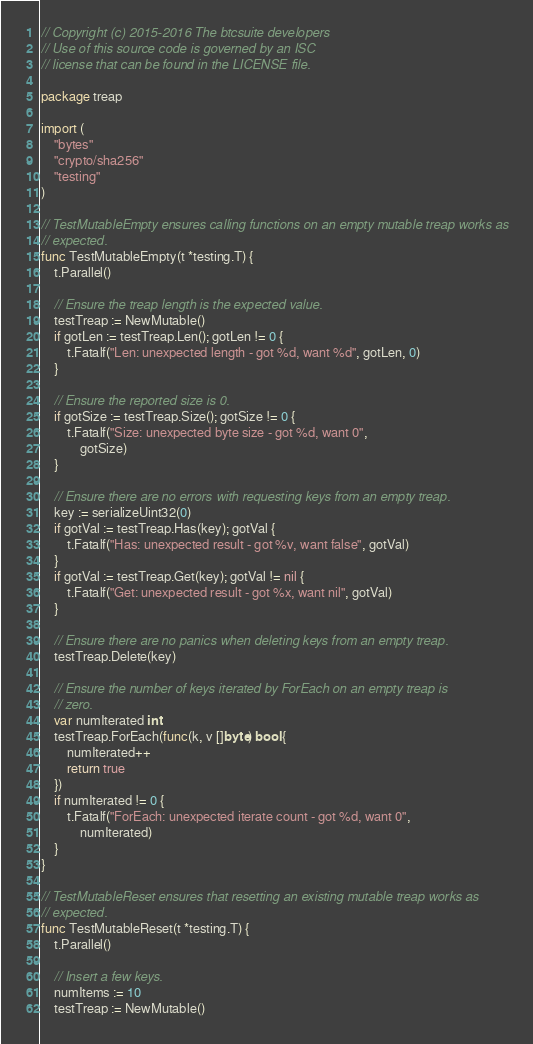Convert code to text. <code><loc_0><loc_0><loc_500><loc_500><_Go_>// Copyright (c) 2015-2016 The btcsuite developers
// Use of this source code is governed by an ISC
// license that can be found in the LICENSE file.

package treap

import (
	"bytes"
	"crypto/sha256"
	"testing"
)

// TestMutableEmpty ensures calling functions on an empty mutable treap works as
// expected.
func TestMutableEmpty(t *testing.T) {
	t.Parallel()

	// Ensure the treap length is the expected value.
	testTreap := NewMutable()
	if gotLen := testTreap.Len(); gotLen != 0 {
		t.Fatalf("Len: unexpected length - got %d, want %d", gotLen, 0)
	}

	// Ensure the reported size is 0.
	if gotSize := testTreap.Size(); gotSize != 0 {
		t.Fatalf("Size: unexpected byte size - got %d, want 0",
			gotSize)
	}

	// Ensure there are no errors with requesting keys from an empty treap.
	key := serializeUint32(0)
	if gotVal := testTreap.Has(key); gotVal {
		t.Fatalf("Has: unexpected result - got %v, want false", gotVal)
	}
	if gotVal := testTreap.Get(key); gotVal != nil {
		t.Fatalf("Get: unexpected result - got %x, want nil", gotVal)
	}

	// Ensure there are no panics when deleting keys from an empty treap.
	testTreap.Delete(key)

	// Ensure the number of keys iterated by ForEach on an empty treap is
	// zero.
	var numIterated int
	testTreap.ForEach(func(k, v []byte) bool {
		numIterated++
		return true
	})
	if numIterated != 0 {
		t.Fatalf("ForEach: unexpected iterate count - got %d, want 0",
			numIterated)
	}
}

// TestMutableReset ensures that resetting an existing mutable treap works as
// expected.
func TestMutableReset(t *testing.T) {
	t.Parallel()

	// Insert a few keys.
	numItems := 10
	testTreap := NewMutable()</code> 